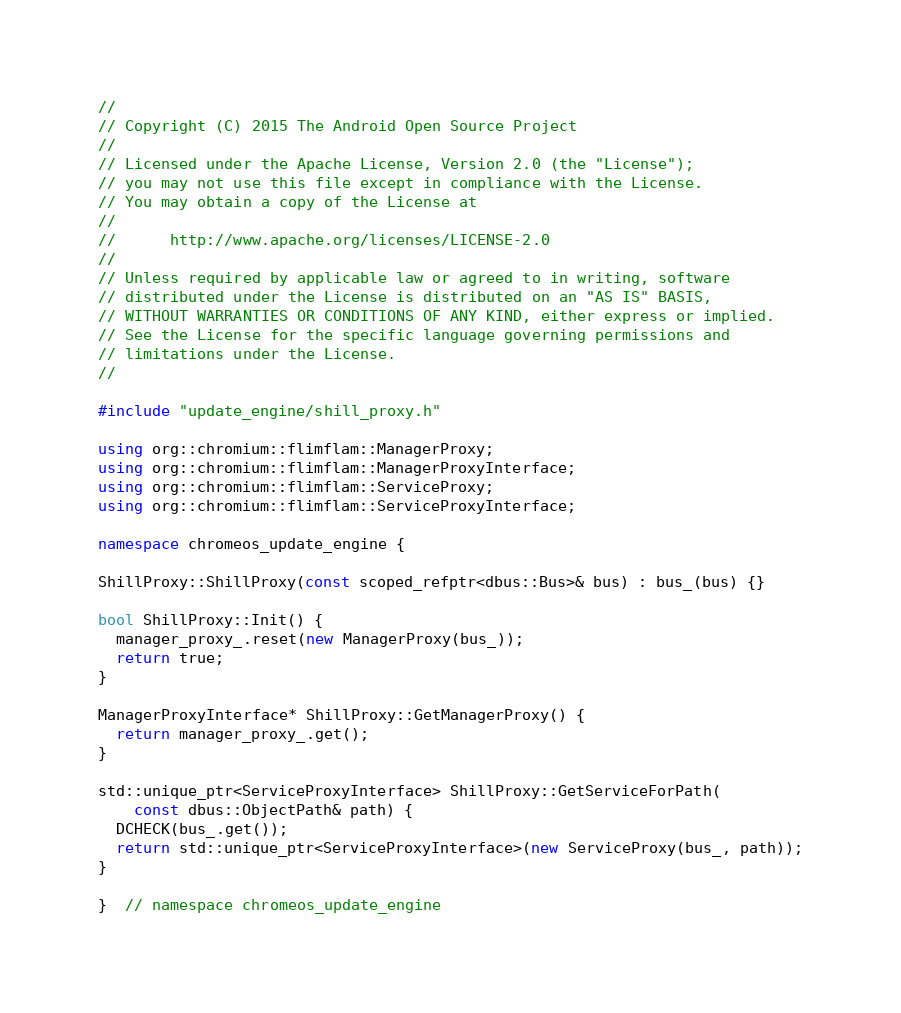Convert code to text. <code><loc_0><loc_0><loc_500><loc_500><_C++_>//
// Copyright (C) 2015 The Android Open Source Project
//
// Licensed under the Apache License, Version 2.0 (the "License");
// you may not use this file except in compliance with the License.
// You may obtain a copy of the License at
//
//      http://www.apache.org/licenses/LICENSE-2.0
//
// Unless required by applicable law or agreed to in writing, software
// distributed under the License is distributed on an "AS IS" BASIS,
// WITHOUT WARRANTIES OR CONDITIONS OF ANY KIND, either express or implied.
// See the License for the specific language governing permissions and
// limitations under the License.
//

#include "update_engine/shill_proxy.h"

using org::chromium::flimflam::ManagerProxy;
using org::chromium::flimflam::ManagerProxyInterface;
using org::chromium::flimflam::ServiceProxy;
using org::chromium::flimflam::ServiceProxyInterface;

namespace chromeos_update_engine {

ShillProxy::ShillProxy(const scoped_refptr<dbus::Bus>& bus) : bus_(bus) {}

bool ShillProxy::Init() {
  manager_proxy_.reset(new ManagerProxy(bus_));
  return true;
}

ManagerProxyInterface* ShillProxy::GetManagerProxy() {
  return manager_proxy_.get();
}

std::unique_ptr<ServiceProxyInterface> ShillProxy::GetServiceForPath(
    const dbus::ObjectPath& path) {
  DCHECK(bus_.get());
  return std::unique_ptr<ServiceProxyInterface>(new ServiceProxy(bus_, path));
}

}  // namespace chromeos_update_engine
</code> 